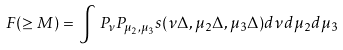<formula> <loc_0><loc_0><loc_500><loc_500>\, F ( \geq M ) = \, \int \, P _ { \nu } P _ { \mu _ { 2 } , \mu _ { 3 } } s ( \nu \Delta , \mu _ { 2 } \Delta , \mu _ { 3 } \Delta ) d \nu d \mu _ { 2 } d \mu _ { 3 }</formula> 